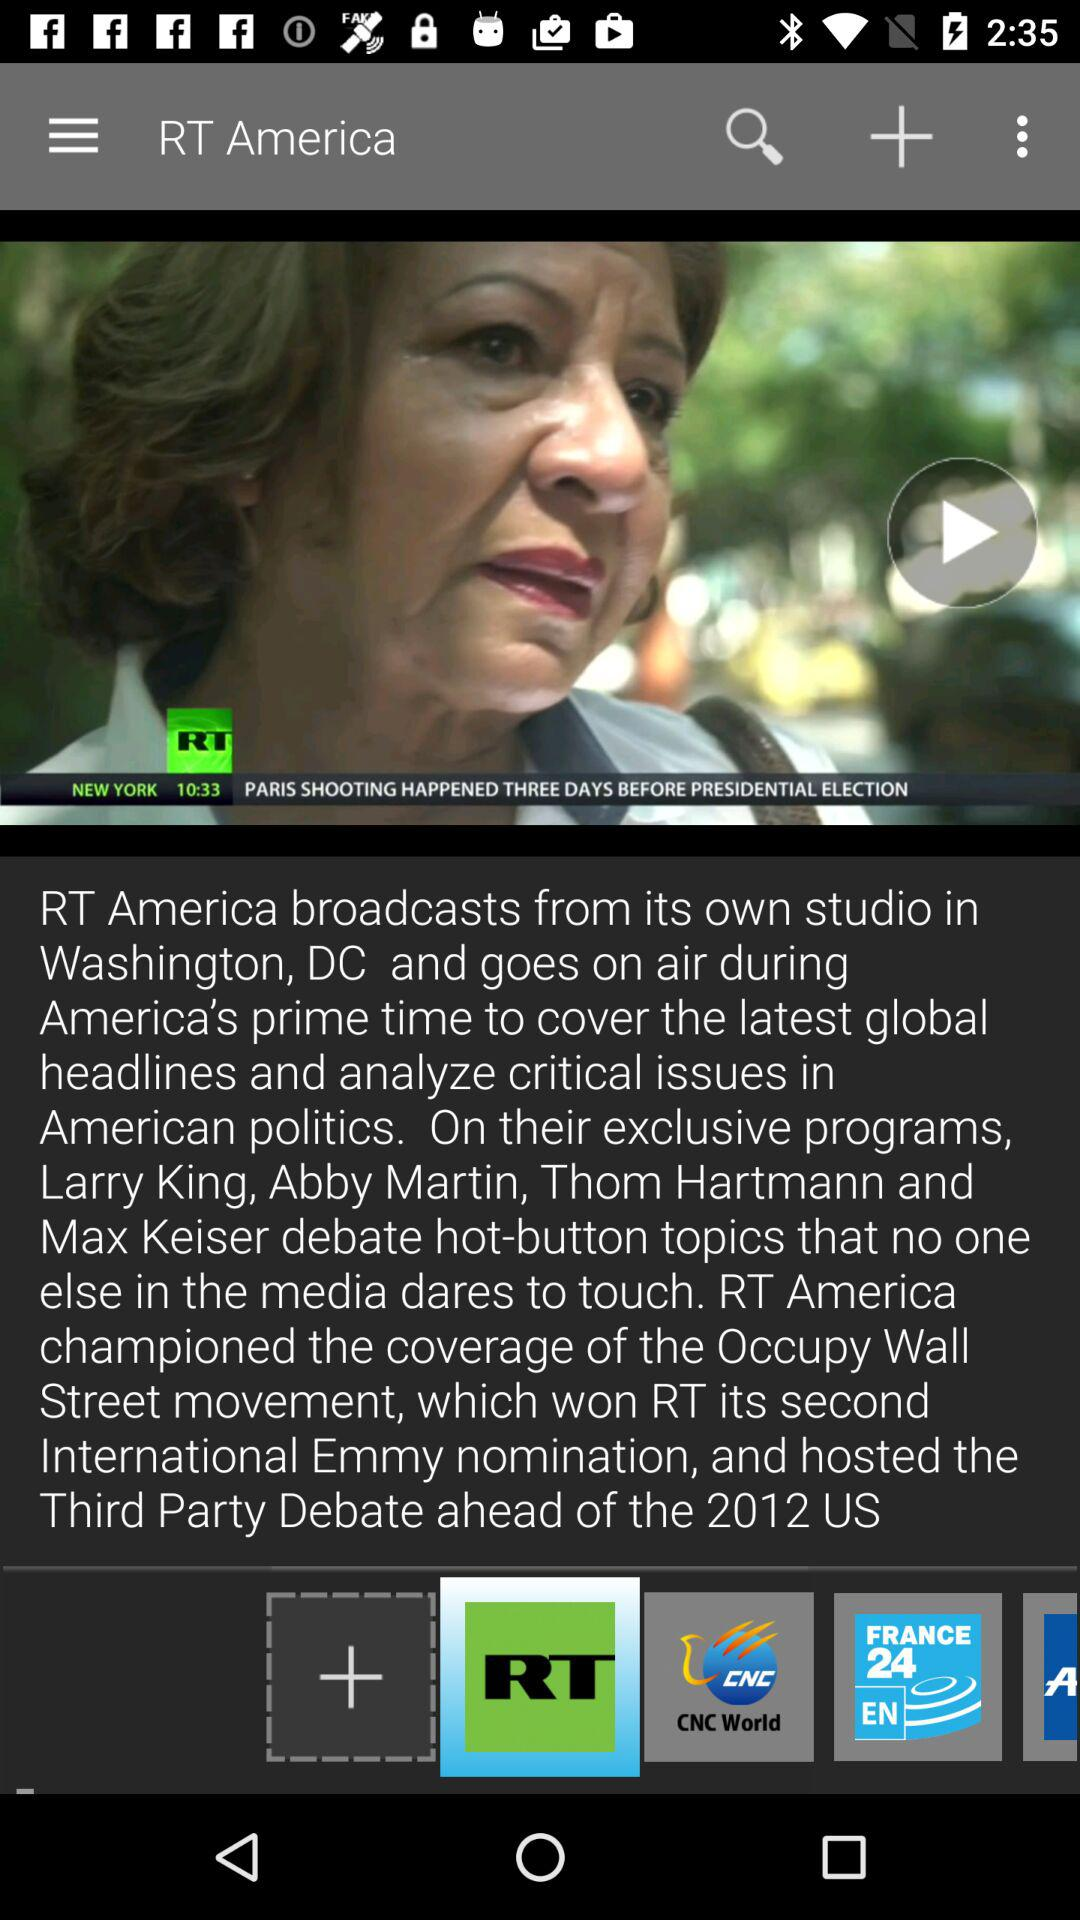What is the application name? The application name is "RT News". 